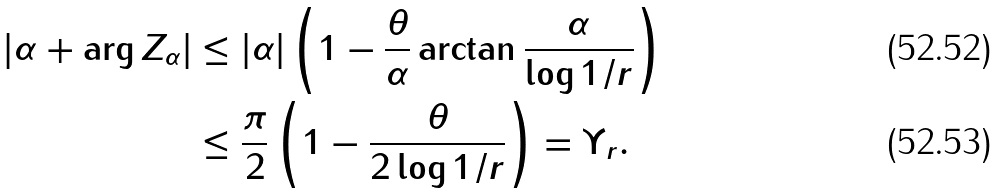<formula> <loc_0><loc_0><loc_500><loc_500>| \alpha + \arg Z _ { \alpha } | & \leq | \alpha | \left ( 1 - \frac { \theta } { \alpha } \arctan \frac { \alpha } { \log 1 / r } \right ) \\ & \leq \frac { \pi } { 2 } \left ( 1 - \frac { \theta } { 2 \log 1 / r } \right ) = \Upsilon _ { r } .</formula> 